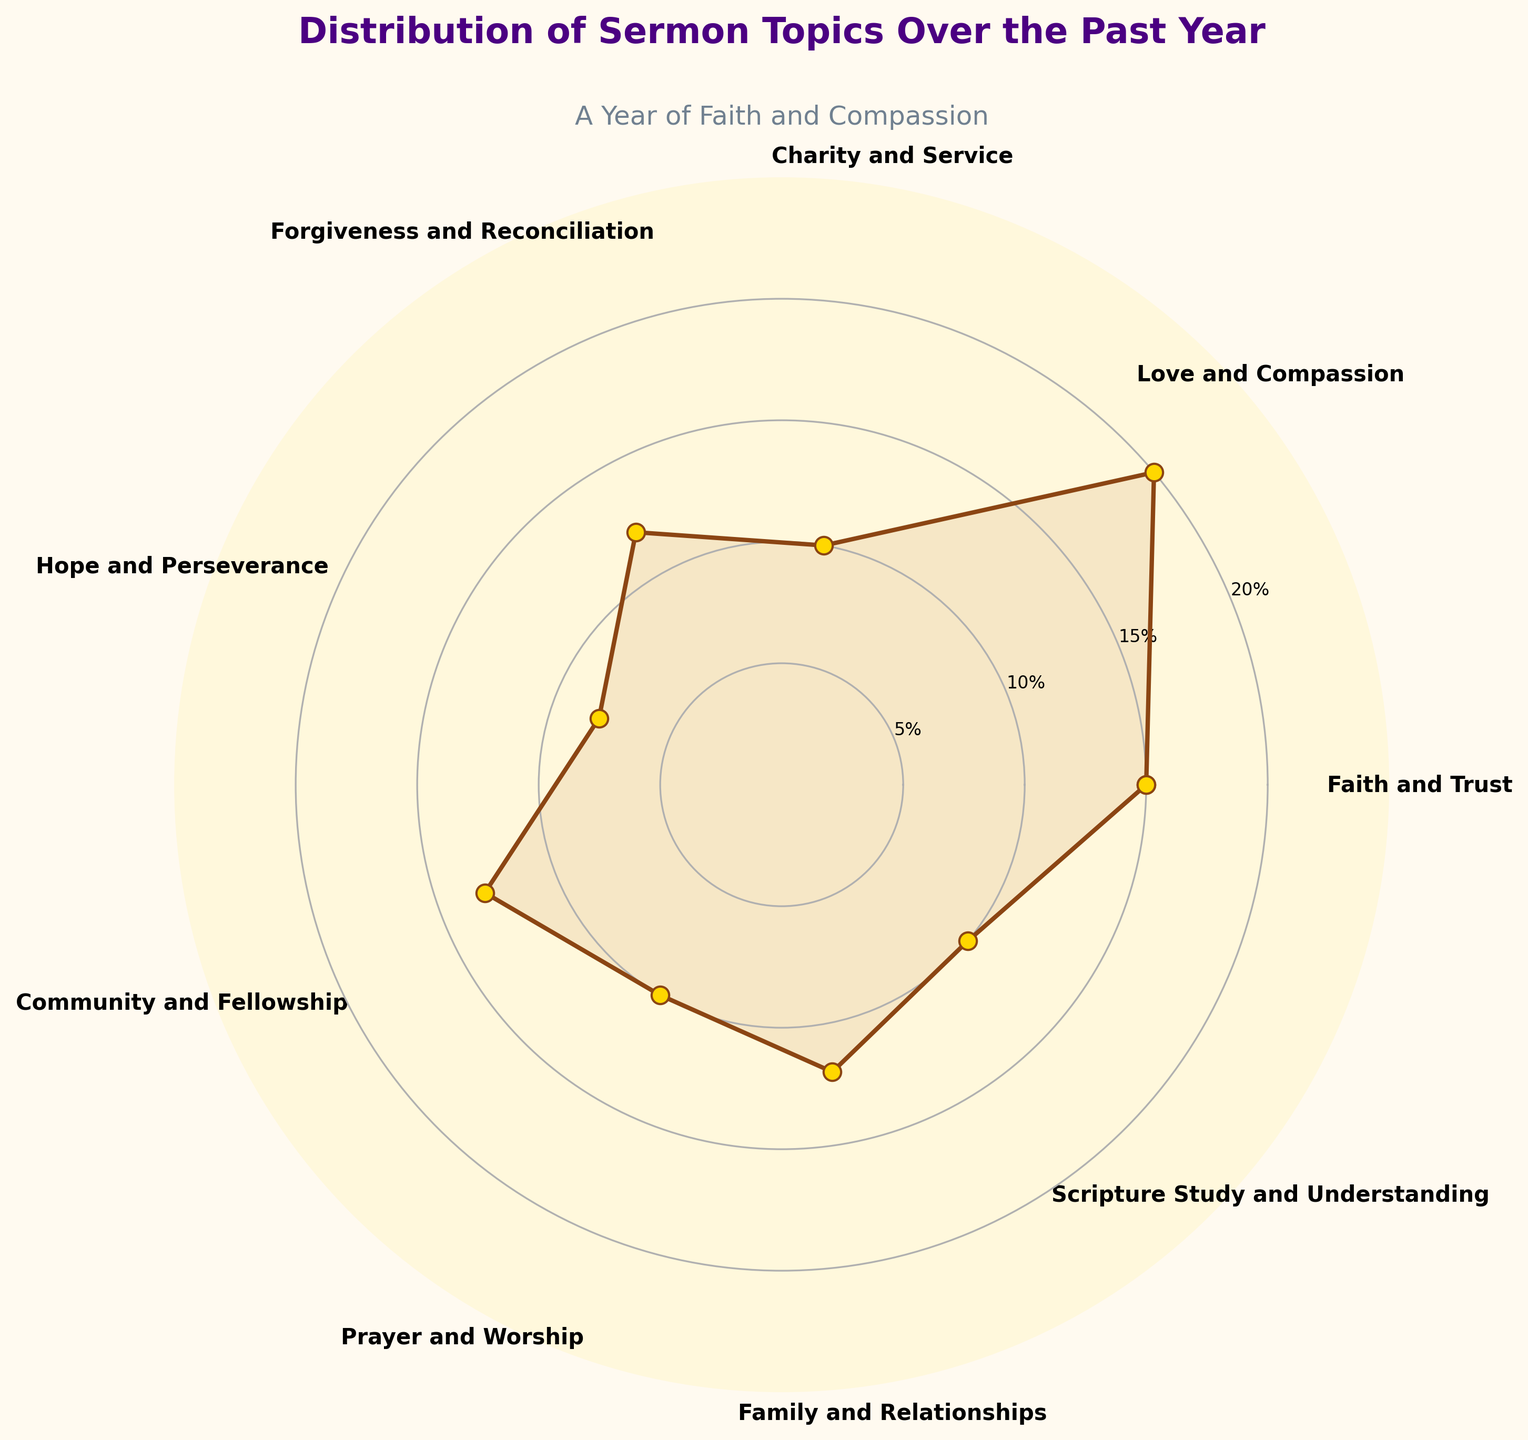what is the title of the chart? The title of the chart is usually indicated at the top and provides an overall description of the data being visualized. The title in this case is "Distribution of Sermon Topics Over the Past Year".
Answer: Distribution of Sermon Topics Over the Past Year What percentage of sermons was focused on Love and Compassion? Locate the segment labeled "Love and Compassion" and read the percentage value associated with it. According to the data, it is 20%.
Answer: 20% Which sermon topic has the highest percentage? By looking at the lengths of the segments or the values associated with each topic, we can identify that "Love and Compassion" has the highest percentage of 20%.
Answer: Love and Compassion How does the percentage for Community and Fellowship compare to Family and Relationships? Look at the percentage values for Community and Fellowship (13%) and Family and Relationships (12%), then compare them. Community and Fellowship is 1% higher than Family and Relationships.
Answer: Community and Fellowship is 1% higher Sum up the percentages for Prayer and Worship, Charity and Service, and Scripture Study and Understanding. Add the percentage values of the topics: Prayer and Worship (10%), Charity and Service (10%), and Scripture Study and Understanding (10%). The total is 10% + 10% + 10% = 30%.
Answer: 30% Which sermons topic has the lowest percentage and by how much less is it compared to Faith and Trust? Identify the topic with the lowest percentage, which is Hope and Perseverance at 8%. Compare it to Faith and Trust, which is 15%. The difference is 15% - 8% = 7%.
Answer: Hope and Perseverance is 7% less What is the average percentage of the topics? Sum all the percentages and divide by the number of topics: (15% + 20% + 10% + 12% + 8% + 13% + 10% + 12% + 10%) / 9. The total is 110%, and the average is 110% / 9 ≈ 12.22%.
Answer: 12.22% Between Forgiveness and Reconciliation and Scripture Study and Understanding, which one is more emphasized and by what percentage? Compare the percentage values: Forgiveness and Reconciliation (12%) and Scripture Study and Understanding (10%). Forgiveness and Reconciliation is emphasized by 2% more.
Answer: Forgiveness and Reconciliation by 2% What's the combined percentage for the top three most discussed topics? Identify the top three percentages: Love and Compassion (20%), Faith and Trust (15%), and Community and Fellowship (13%). Sum these percentages: 20% + 15% + 13% = 48%.
Answer: 48% What is the difference in percentage between Faith and Trust and Charity and Service? Subtract the percentage of Charity and Service (10%) from Faith and Trust (15%): 15% - 10% = 5%.
Answer: 5% 